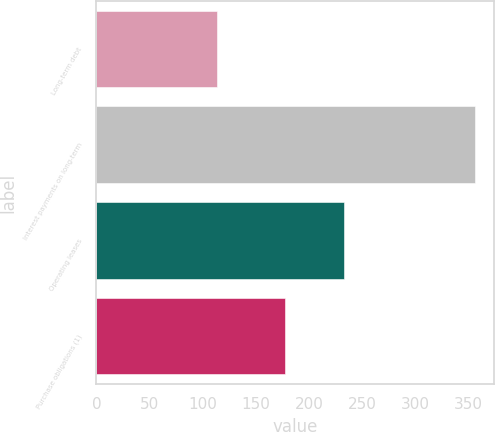<chart> <loc_0><loc_0><loc_500><loc_500><bar_chart><fcel>Long-term debt<fcel>Interest payments on long-term<fcel>Operating leases<fcel>Purchase obligations (1)<nl><fcel>113<fcel>356<fcel>233<fcel>177<nl></chart> 